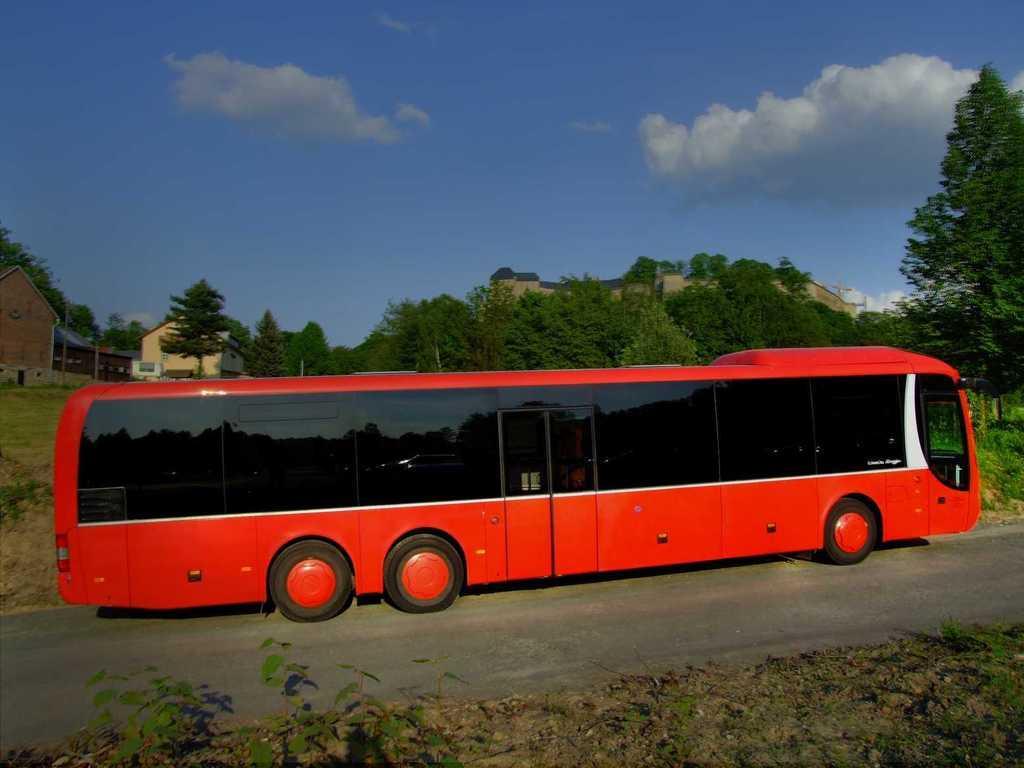Can you describe this image briefly? In the center of the image we can see a bus on the road. In the background there are sheds, trees and sky. 